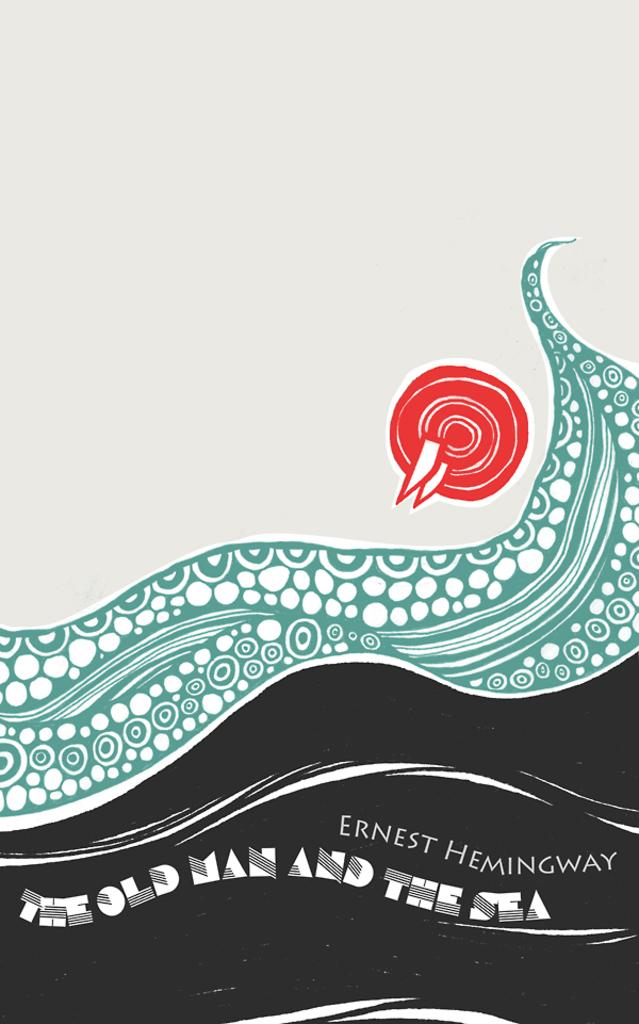<image>
Present a compact description of the photo's key features. the cover of a book for The Old Man and the Sea 